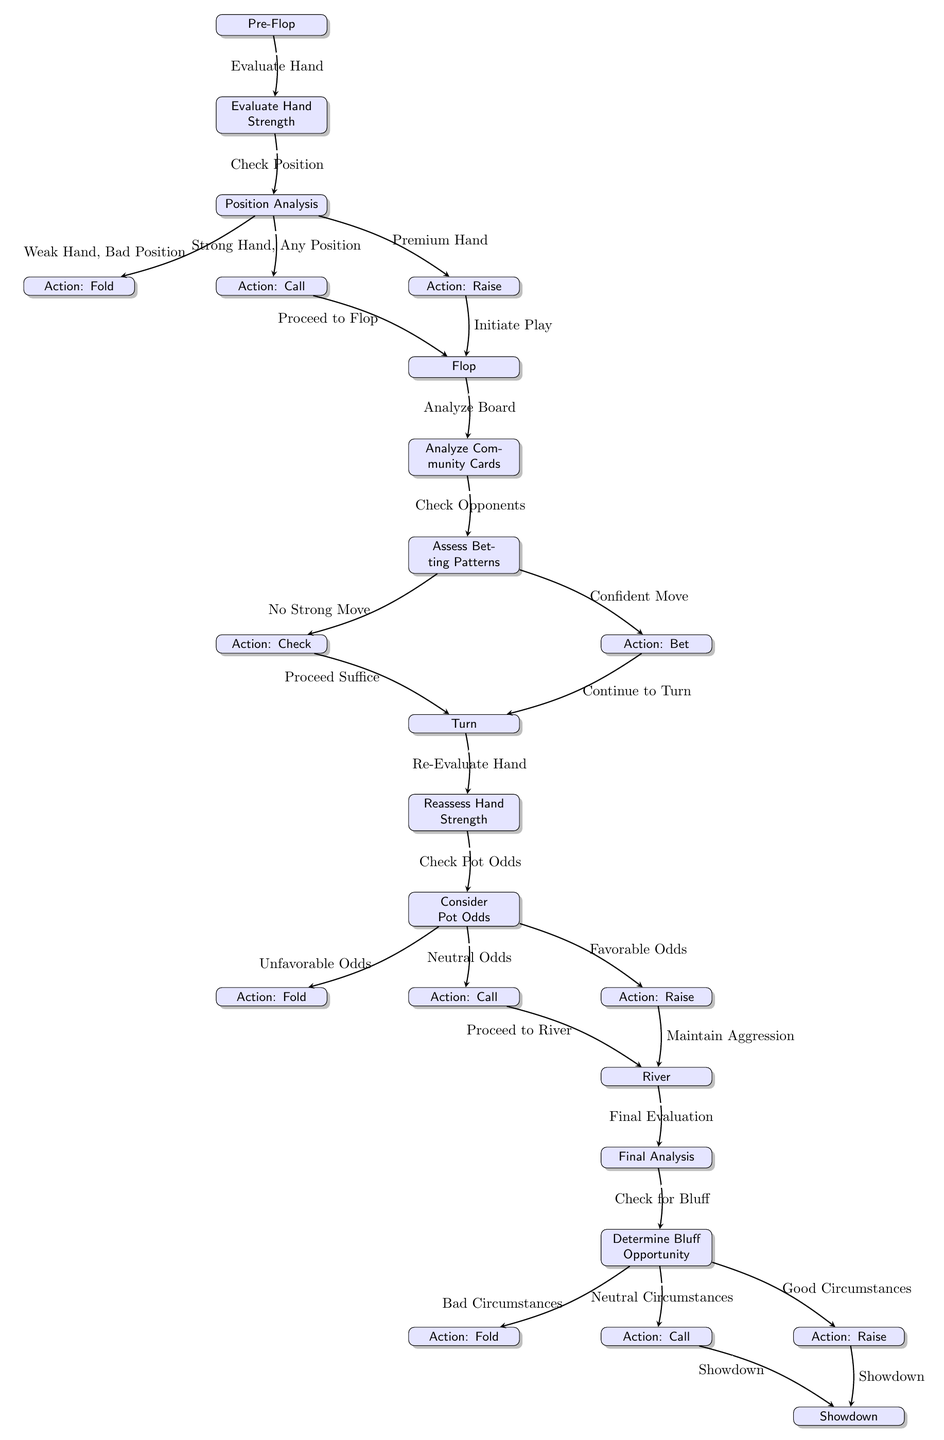What is the first step in the flowchart? The first node in the flowchart is labeled "Pre-Flop," indicating that this is the initial decision-making stage in the poker hand strategy.
Answer: Pre-Flop How many actions are listed after "Position Analysis"? After "Position Analysis," there are three possible actions: "Action: Fold," "Action: Call," and "Action: Raise," which indicates the options available based on the player’s position and hand strength.
Answer: Three What happens if the player has a weak hand in a bad position? If the player has a weak hand in a bad position, the flowchart indicates the action is to "Fold," as shown in the node path leading from "Position Analysis."
Answer: Action: Fold What is the decision point after "Assess Betting Patterns"? The decision point after "Assess Betting Patterns" consists of two possible actions: "Action: Check" if there is no strong move, and "Action: Bet" if there’s a confident move.
Answer: Action: Check or Action: Bet If the pot odds are favorable after the turn, what action should the player take? If the pot odds are favorable, the flowchart directs the player to "Action: Raise," showing that this is the recommended action in such circumstances of potential profit.
Answer: Action: Raise What name is given to the phase after the Flop? The phase immediately following the Flop in the flowchart is labeled "Turn," indicating the next betting round where players reassess their hands and the board.
Answer: Turn In the river phase, what should be done after the final analysis? After the "Final Analysis" in the river phase, the flowchart suggests that the player should "Determine Bluff Opportunity" as the next logical step in decision-making.
Answer: Determine Bluff Opportunity How does a player proceed if they assess "Neutral Odds" after the Turn? If the player assesses "Neutral Odds" after the Turn, the flowchart indicates that the action is to "Action: Call," suggesting that they should continue in the hand without raising.
Answer: Action: Call What action is taken during a showdown after neutral circumstances on the river? In the case of neutral circumstances during a showdown on the river, the flowchart specifies that the player should proceed to "Showdown."
Answer: Showdown 